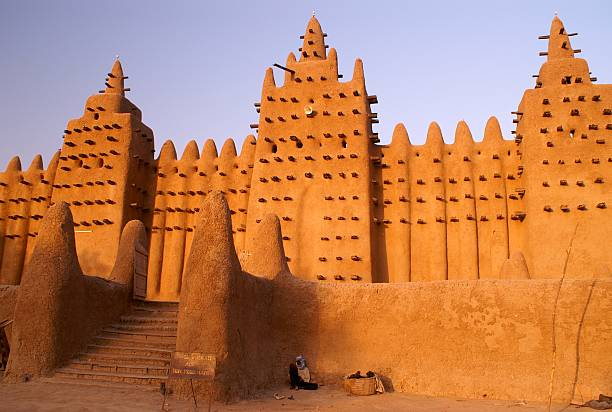Imagine this mosque could speak. What stories would it tell? If the Great Mosque of Djenné could speak, it would narrate tales of centuries past, when caravans laden with gold, salt, and manuscripts traversed the Sahara, stopping here to trade. It would recount the days when scholars from far and wide gathered within its walls, debating and documenting knowledge that would ripple through time. It would speak of the communal efforts each year, where every villager, from children to elders, lends a hand in the annual re-plastering ceremony, a tradition that pays homage to their ancestors. The mosque would also whisper of prayers offered at dawn and dusk, moments of quiet reflection, and the calls to prayer that echo through the streets, binding the community in a shared rhythm of life. 